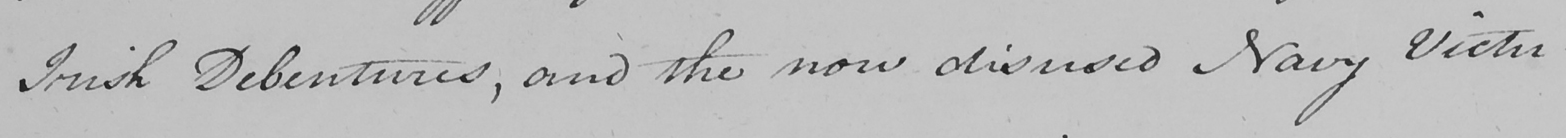Transcribe the text shown in this historical manuscript line. Irish Debentures , and the now disused Navy Victu- 